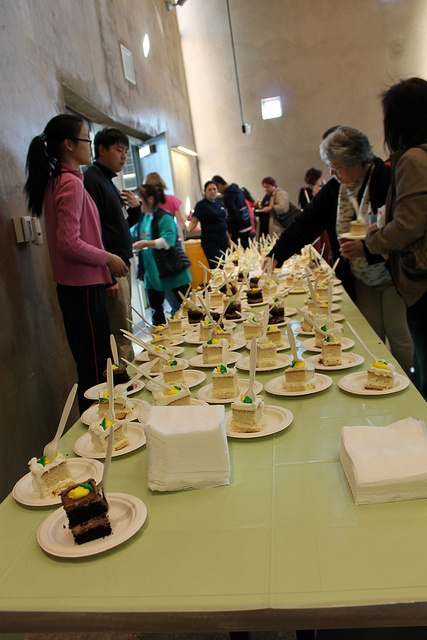Describe the objects in this image and their specific colors. I can see dining table in gray, tan, and olive tones, people in gray, black, maroon, and brown tones, people in gray, black, and maroon tones, cake in gray, tan, olive, and black tones, and people in gray, black, and maroon tones in this image. 